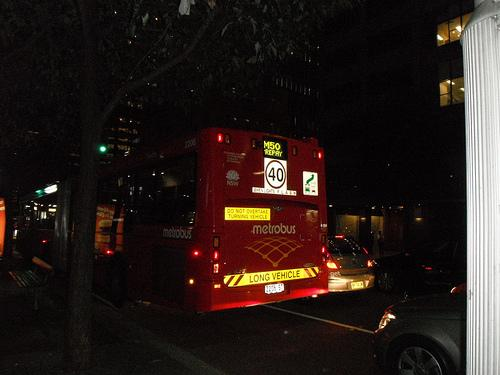Mention a feature of the bus that may indicate its type or purpose. There is a metrobus logo on the bus, suggesting it is a public transport bus. Briefly describe the relationship between the bus and the car mentioned in the image. The bus is on the road and there is a car close to it, possibly behind or beside the bus. What can be observed about the environment and lighting conditions in the image? It appears to be a dark street, possibly nighttime with several lights on in buildings and on the street. What warning sign can be seen on the back of the bus? A yellow sign with the number 40 on it. Count the number of tail lights on the back of the bus. There are two tail lights on the back of the bus. Identify two colors mentioned in the image and the objects associated with them. The bus is red, and the signs are yellow. Does the tree adjacent to the bus have pink flowers? No, it's not mentioned in the image. Are the front tires of the vehicle purple? The information about the tire is provided as "front tire on a vehicle X:395 Y:343 Width:55 Height:55", with no mention of any unusual color such as purple. 